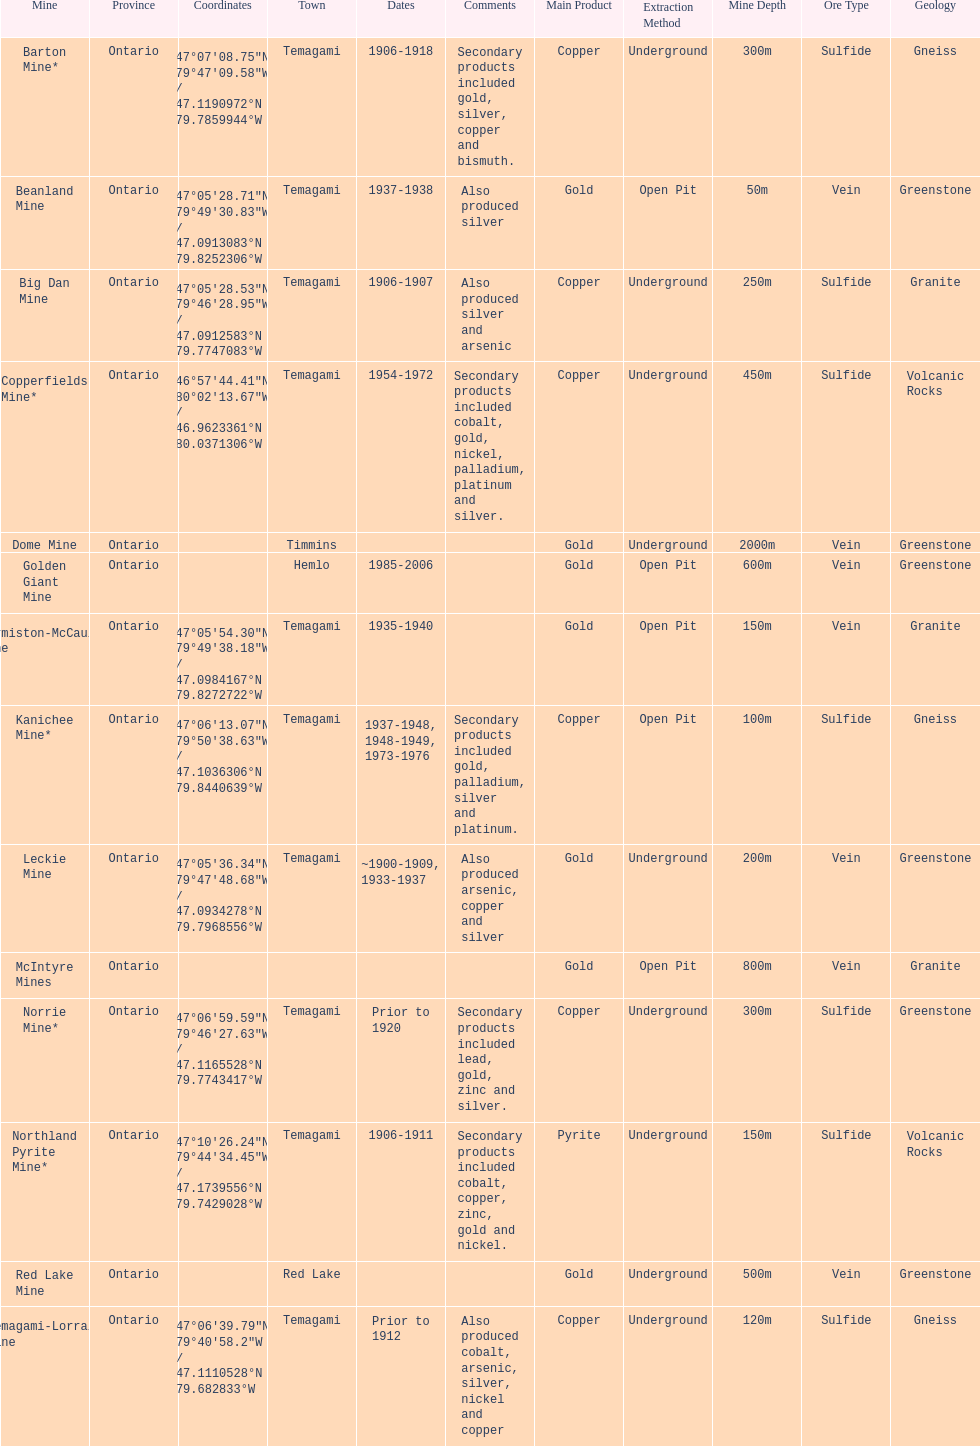Name a gold mine that was open at least 10 years. Barton Mine. 